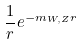Convert formula to latex. <formula><loc_0><loc_0><loc_500><loc_500>\frac { 1 } { r } e ^ { - m _ { W , Z } r }</formula> 